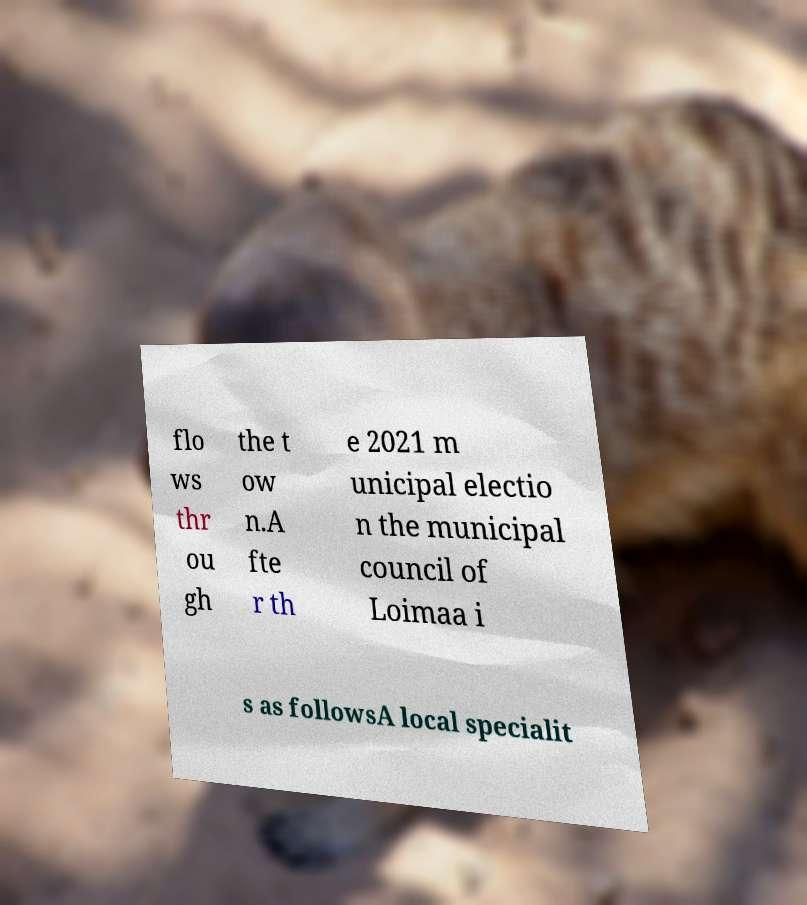What messages or text are displayed in this image? I need them in a readable, typed format. flo ws thr ou gh the t ow n.A fte r th e 2021 m unicipal electio n the municipal council of Loimaa i s as followsA local specialit 